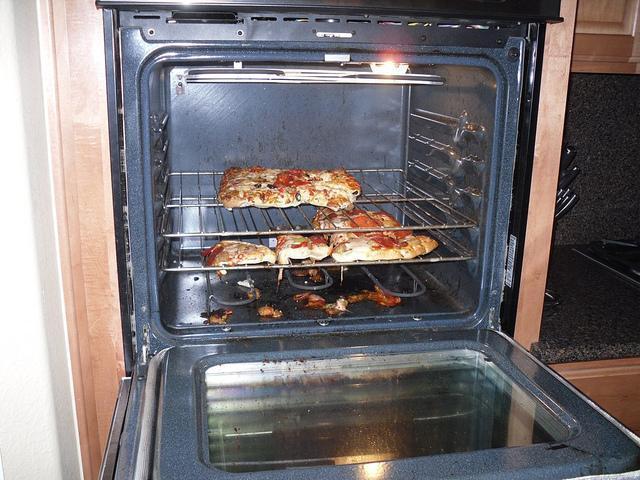Verify the accuracy of this image caption: "The pizza is in the oven.".
Answer yes or no. Yes. 